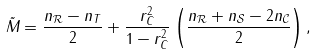Convert formula to latex. <formula><loc_0><loc_0><loc_500><loc_500>\tilde { M } _ { \| \| } = \frac { n _ { \mathcal { R } } - n _ { T } } { 2 } + \frac { r _ { C } ^ { 2 } } { 1 - r _ { C } ^ { 2 } } \left ( \frac { n _ { \mathcal { R } } + n _ { \mathcal { S } } - 2 n _ { \mathcal { C } } } { 2 } \right ) ,</formula> 